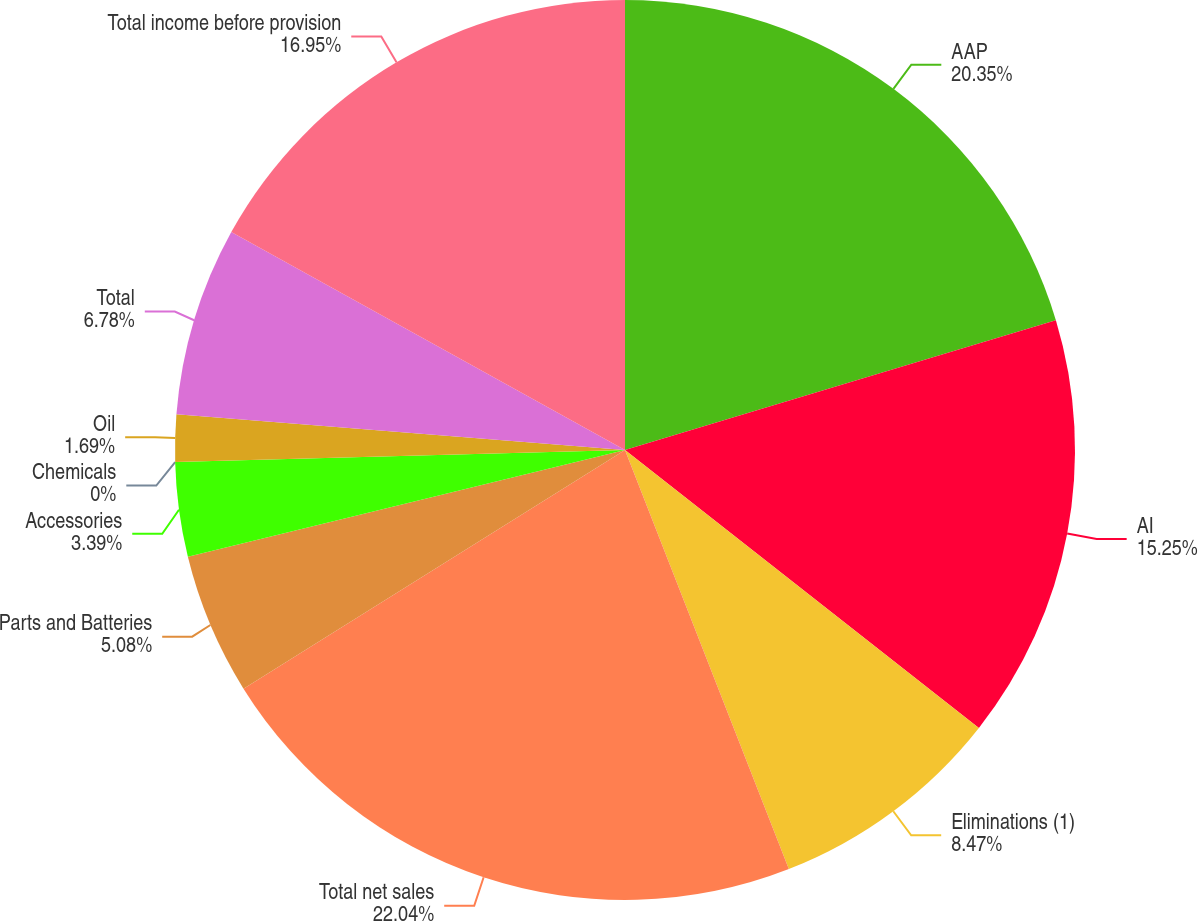Convert chart to OTSL. <chart><loc_0><loc_0><loc_500><loc_500><pie_chart><fcel>AAP<fcel>AI<fcel>Eliminations (1)<fcel>Total net sales<fcel>Parts and Batteries<fcel>Accessories<fcel>Chemicals<fcel>Oil<fcel>Total<fcel>Total income before provision<nl><fcel>20.34%<fcel>15.25%<fcel>8.47%<fcel>22.03%<fcel>5.08%<fcel>3.39%<fcel>0.0%<fcel>1.69%<fcel>6.78%<fcel>16.95%<nl></chart> 